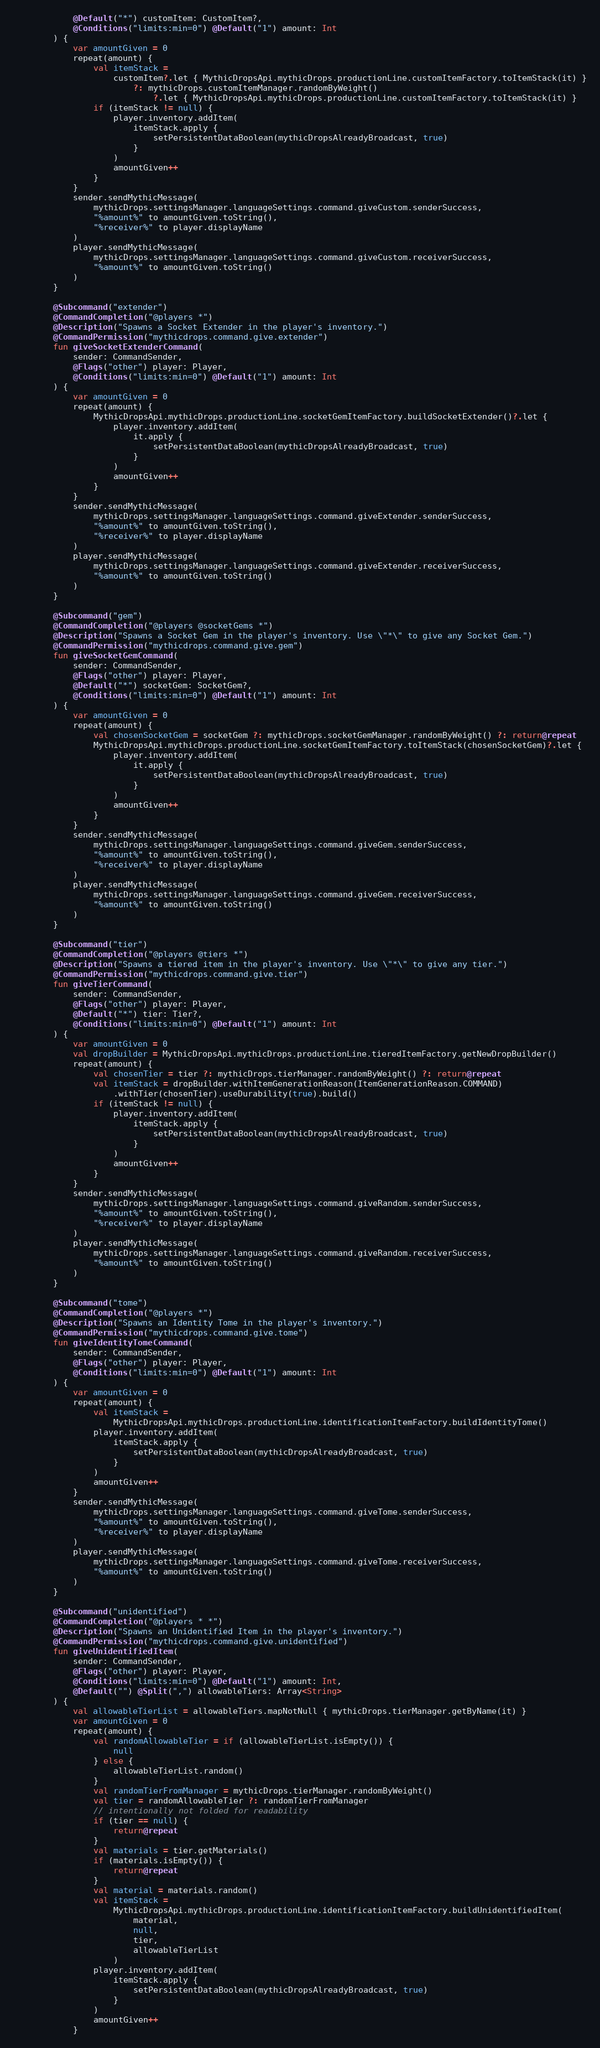Convert code to text. <code><loc_0><loc_0><loc_500><loc_500><_Kotlin_>            @Default("*") customItem: CustomItem?,
            @Conditions("limits:min=0") @Default("1") amount: Int
        ) {
            var amountGiven = 0
            repeat(amount) {
                val itemStack =
                    customItem?.let { MythicDropsApi.mythicDrops.productionLine.customItemFactory.toItemStack(it) }
                        ?: mythicDrops.customItemManager.randomByWeight()
                            ?.let { MythicDropsApi.mythicDrops.productionLine.customItemFactory.toItemStack(it) }
                if (itemStack != null) {
                    player.inventory.addItem(
                        itemStack.apply {
                            setPersistentDataBoolean(mythicDropsAlreadyBroadcast, true)
                        }
                    )
                    amountGiven++
                }
            }
            sender.sendMythicMessage(
                mythicDrops.settingsManager.languageSettings.command.giveCustom.senderSuccess,
                "%amount%" to amountGiven.toString(),
                "%receiver%" to player.displayName
            )
            player.sendMythicMessage(
                mythicDrops.settingsManager.languageSettings.command.giveCustom.receiverSuccess,
                "%amount%" to amountGiven.toString()
            )
        }

        @Subcommand("extender")
        @CommandCompletion("@players *")
        @Description("Spawns a Socket Extender in the player's inventory.")
        @CommandPermission("mythicdrops.command.give.extender")
        fun giveSocketExtenderCommand(
            sender: CommandSender,
            @Flags("other") player: Player,
            @Conditions("limits:min=0") @Default("1") amount: Int
        ) {
            var amountGiven = 0
            repeat(amount) {
                MythicDropsApi.mythicDrops.productionLine.socketGemItemFactory.buildSocketExtender()?.let {
                    player.inventory.addItem(
                        it.apply {
                            setPersistentDataBoolean(mythicDropsAlreadyBroadcast, true)
                        }
                    )
                    amountGiven++
                }
            }
            sender.sendMythicMessage(
                mythicDrops.settingsManager.languageSettings.command.giveExtender.senderSuccess,
                "%amount%" to amountGiven.toString(),
                "%receiver%" to player.displayName
            )
            player.sendMythicMessage(
                mythicDrops.settingsManager.languageSettings.command.giveExtender.receiverSuccess,
                "%amount%" to amountGiven.toString()
            )
        }

        @Subcommand("gem")
        @CommandCompletion("@players @socketGems *")
        @Description("Spawns a Socket Gem in the player's inventory. Use \"*\" to give any Socket Gem.")
        @CommandPermission("mythicdrops.command.give.gem")
        fun giveSocketGemCommand(
            sender: CommandSender,
            @Flags("other") player: Player,
            @Default("*") socketGem: SocketGem?,
            @Conditions("limits:min=0") @Default("1") amount: Int
        ) {
            var amountGiven = 0
            repeat(amount) {
                val chosenSocketGem = socketGem ?: mythicDrops.socketGemManager.randomByWeight() ?: return@repeat
                MythicDropsApi.mythicDrops.productionLine.socketGemItemFactory.toItemStack(chosenSocketGem)?.let {
                    player.inventory.addItem(
                        it.apply {
                            setPersistentDataBoolean(mythicDropsAlreadyBroadcast, true)
                        }
                    )
                    amountGiven++
                }
            }
            sender.sendMythicMessage(
                mythicDrops.settingsManager.languageSettings.command.giveGem.senderSuccess,
                "%amount%" to amountGiven.toString(),
                "%receiver%" to player.displayName
            )
            player.sendMythicMessage(
                mythicDrops.settingsManager.languageSettings.command.giveGem.receiverSuccess,
                "%amount%" to amountGiven.toString()
            )
        }

        @Subcommand("tier")
        @CommandCompletion("@players @tiers *")
        @Description("Spawns a tiered item in the player's inventory. Use \"*\" to give any tier.")
        @CommandPermission("mythicdrops.command.give.tier")
        fun giveTierCommand(
            sender: CommandSender,
            @Flags("other") player: Player,
            @Default("*") tier: Tier?,
            @Conditions("limits:min=0") @Default("1") amount: Int
        ) {
            var amountGiven = 0
            val dropBuilder = MythicDropsApi.mythicDrops.productionLine.tieredItemFactory.getNewDropBuilder()
            repeat(amount) {
                val chosenTier = tier ?: mythicDrops.tierManager.randomByWeight() ?: return@repeat
                val itemStack = dropBuilder.withItemGenerationReason(ItemGenerationReason.COMMAND)
                    .withTier(chosenTier).useDurability(true).build()
                if (itemStack != null) {
                    player.inventory.addItem(
                        itemStack.apply {
                            setPersistentDataBoolean(mythicDropsAlreadyBroadcast, true)
                        }
                    )
                    amountGiven++
                }
            }
            sender.sendMythicMessage(
                mythicDrops.settingsManager.languageSettings.command.giveRandom.senderSuccess,
                "%amount%" to amountGiven.toString(),
                "%receiver%" to player.displayName
            )
            player.sendMythicMessage(
                mythicDrops.settingsManager.languageSettings.command.giveRandom.receiverSuccess,
                "%amount%" to amountGiven.toString()
            )
        }

        @Subcommand("tome")
        @CommandCompletion("@players *")
        @Description("Spawns an Identity Tome in the player's inventory.")
        @CommandPermission("mythicdrops.command.give.tome")
        fun giveIdentityTomeCommand(
            sender: CommandSender,
            @Flags("other") player: Player,
            @Conditions("limits:min=0") @Default("1") amount: Int
        ) {
            var amountGiven = 0
            repeat(amount) {
                val itemStack =
                    MythicDropsApi.mythicDrops.productionLine.identificationItemFactory.buildIdentityTome()
                player.inventory.addItem(
                    itemStack.apply {
                        setPersistentDataBoolean(mythicDropsAlreadyBroadcast, true)
                    }
                )
                amountGiven++
            }
            sender.sendMythicMessage(
                mythicDrops.settingsManager.languageSettings.command.giveTome.senderSuccess,
                "%amount%" to amountGiven.toString(),
                "%receiver%" to player.displayName
            )
            player.sendMythicMessage(
                mythicDrops.settingsManager.languageSettings.command.giveTome.receiverSuccess,
                "%amount%" to amountGiven.toString()
            )
        }

        @Subcommand("unidentified")
        @CommandCompletion("@players * *")
        @Description("Spawns an Unidentified Item in the player's inventory.")
        @CommandPermission("mythicdrops.command.give.unidentified")
        fun giveUnidentifiedItem(
            sender: CommandSender,
            @Flags("other") player: Player,
            @Conditions("limits:min=0") @Default("1") amount: Int,
            @Default("") @Split(",") allowableTiers: Array<String>
        ) {
            val allowableTierList = allowableTiers.mapNotNull { mythicDrops.tierManager.getByName(it) }
            var amountGiven = 0
            repeat(amount) {
                val randomAllowableTier = if (allowableTierList.isEmpty()) {
                    null
                } else {
                    allowableTierList.random()
                }
                val randomTierFromManager = mythicDrops.tierManager.randomByWeight()
                val tier = randomAllowableTier ?: randomTierFromManager
                // intentionally not folded for readability
                if (tier == null) {
                    return@repeat
                }
                val materials = tier.getMaterials()
                if (materials.isEmpty()) {
                    return@repeat
                }
                val material = materials.random()
                val itemStack =
                    MythicDropsApi.mythicDrops.productionLine.identificationItemFactory.buildUnidentifiedItem(
                        material,
                        null,
                        tier,
                        allowableTierList
                    )
                player.inventory.addItem(
                    itemStack.apply {
                        setPersistentDataBoolean(mythicDropsAlreadyBroadcast, true)
                    }
                )
                amountGiven++
            }</code> 